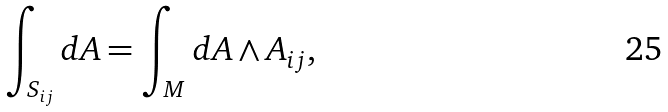Convert formula to latex. <formula><loc_0><loc_0><loc_500><loc_500>\int _ { S _ { i j } } d A = \int _ { M } d A \wedge A _ { i j } ,</formula> 